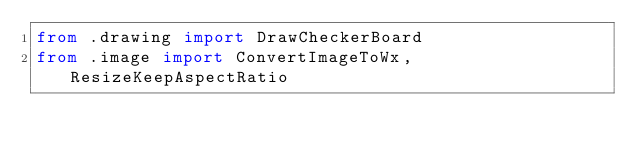<code> <loc_0><loc_0><loc_500><loc_500><_Python_>from .drawing import DrawCheckerBoard
from .image import ConvertImageToWx, ResizeKeepAspectRatio
</code> 